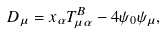Convert formula to latex. <formula><loc_0><loc_0><loc_500><loc_500>D _ { \mu } = x _ { \alpha } T _ { \mu \alpha } ^ { B } - 4 \psi _ { 0 } \psi _ { \mu } ,</formula> 